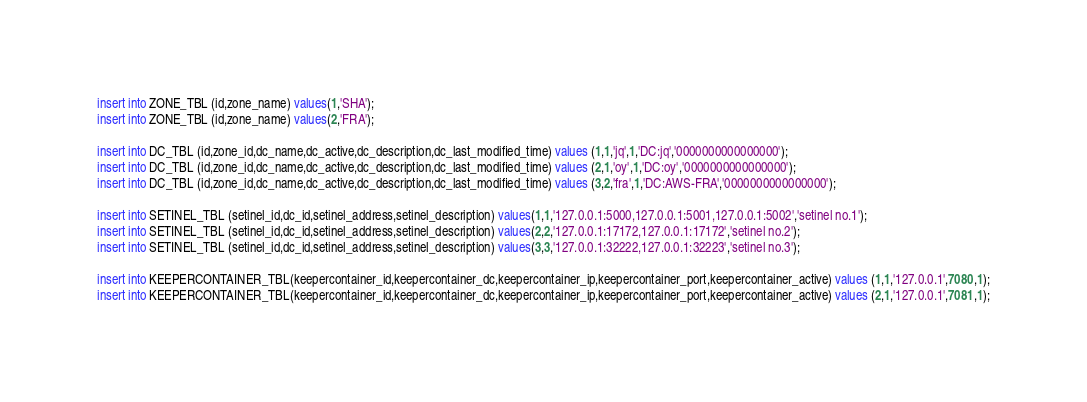Convert code to text. <code><loc_0><loc_0><loc_500><loc_500><_SQL_>insert into ZONE_TBL (id,zone_name) values(1,'SHA');
insert into ZONE_TBL (id,zone_name) values(2,'FRA');

insert into DC_TBL (id,zone_id,dc_name,dc_active,dc_description,dc_last_modified_time) values (1,1,'jq',1,'DC:jq','0000000000000000');
insert into DC_TBL (id,zone_id,dc_name,dc_active,dc_description,dc_last_modified_time) values (2,1,'oy',1,'DC:oy','0000000000000000');
insert into DC_TBL (id,zone_id,dc_name,dc_active,dc_description,dc_last_modified_time) values (3,2,'fra',1,'DC:AWS-FRA','0000000000000000');

insert into SETINEL_TBL (setinel_id,dc_id,setinel_address,setinel_description) values(1,1,'127.0.0.1:5000,127.0.0.1:5001,127.0.0.1:5002','setinel no.1');
insert into SETINEL_TBL (setinel_id,dc_id,setinel_address,setinel_description) values(2,2,'127.0.0.1:17172,127.0.0.1:17172','setinel no.2');
insert into SETINEL_TBL (setinel_id,dc_id,setinel_address,setinel_description) values(3,3,'127.0.0.1:32222,127.0.0.1:32223','setinel no.3');

insert into KEEPERCONTAINER_TBL(keepercontainer_id,keepercontainer_dc,keepercontainer_ip,keepercontainer_port,keepercontainer_active) values (1,1,'127.0.0.1',7080,1);
insert into KEEPERCONTAINER_TBL(keepercontainer_id,keepercontainer_dc,keepercontainer_ip,keepercontainer_port,keepercontainer_active) values (2,1,'127.0.0.1',7081,1);</code> 